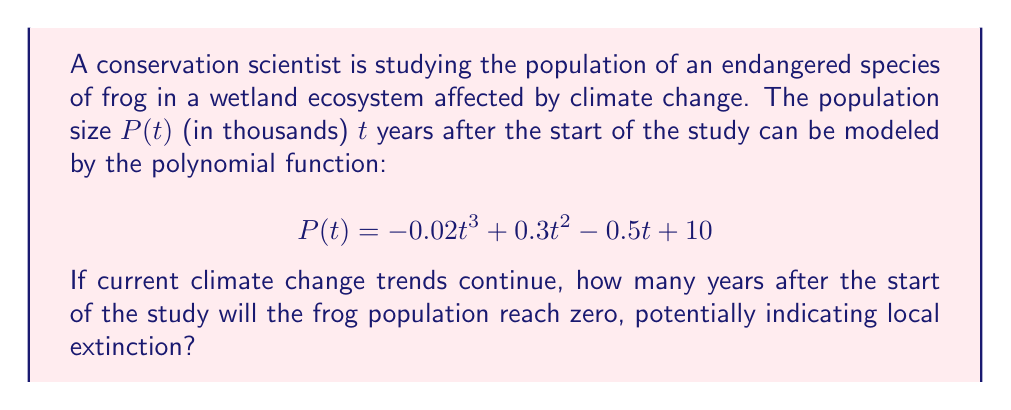Help me with this question. To solve this problem, we need to find the positive root of the polynomial equation:

$$-0.02t^3 + 0.3t^2 - 0.5t + 10 = 0$$

Let's approach this step-by-step:

1) First, we can factor out the greatest common factor:
   $$0.02(-t^3 + 15t^2 - 25t + 500) = 0$$

2) The cubic equation doesn't have obvious rational roots, so we'll use the rational root theorem. The possible rational roots are the factors of the constant term (500): ±1, ±2, ±4, ±5, ±10, ±20, ±25, ±50, ±100, ±125, ±250, ±500.

3) Testing these values, we find that t = 10 is a root of the equation.

4) Using polynomial long division or synthetic division, we can factor the equation:
   $$-0.02(t - 10)(t^2 - 5t - 50) = 0$$

5) Using the quadratic formula on $t^2 - 5t - 50 = 0$:
   $$t = \frac{5 \pm \sqrt{25 + 200}}{2} = \frac{5 \pm \sqrt{225}}{2} = \frac{5 \pm 15}{2}$$

6) This gives us two more roots: $t = 10$ and $t = -5$

7) The three roots of the equation are therefore 10, 10, and -5.

8) Since we're looking for the time in the future when the population reaches zero, and negative time doesn't make sense in this context, the answer is 10 years.
Answer: 10 years 